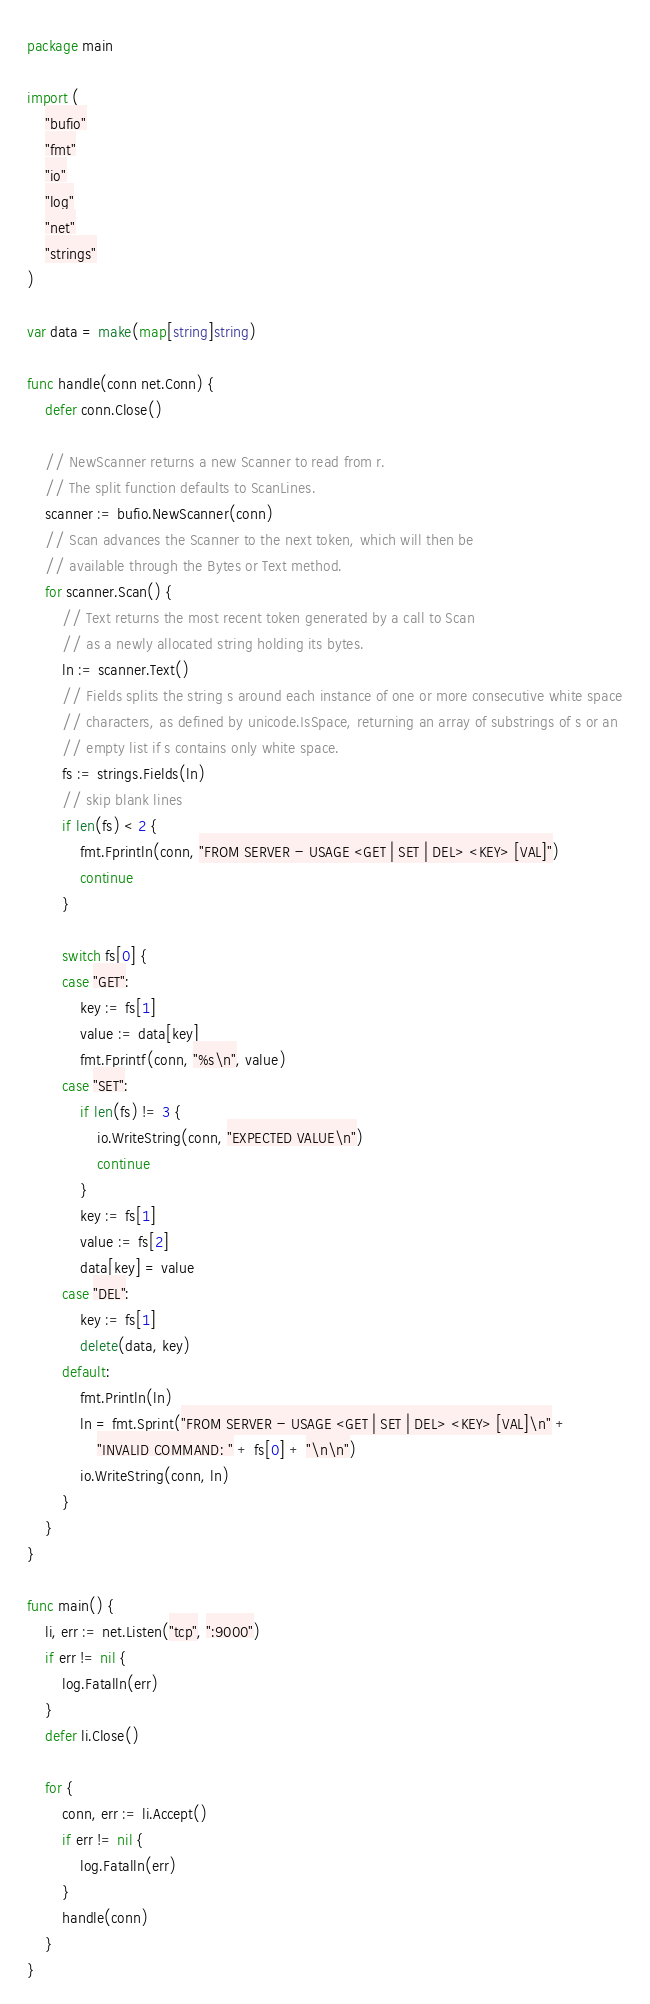Convert code to text. <code><loc_0><loc_0><loc_500><loc_500><_Go_>package main

import (
	"bufio"
	"fmt"
	"io"
	"log"
	"net"
	"strings"
)

var data = make(map[string]string)

func handle(conn net.Conn) {
	defer conn.Close()

	// NewScanner returns a new Scanner to read from r.
	// The split function defaults to ScanLines.
	scanner := bufio.NewScanner(conn)
	// Scan advances the Scanner to the next token, which will then be
	// available through the Bytes or Text method.
	for scanner.Scan() {
		// Text returns the most recent token generated by a call to Scan
		// as a newly allocated string holding its bytes.
		ln := scanner.Text()
		// Fields splits the string s around each instance of one or more consecutive white space
		// characters, as defined by unicode.IsSpace, returning an array of substrings of s or an
		// empty list if s contains only white space.
		fs := strings.Fields(ln)
		// skip blank lines
		if len(fs) < 2 {
			fmt.Fprintln(conn, "FROM SERVER - USAGE <GET | SET | DEL> <KEY> [VAL]")
			continue
		}

		switch fs[0] {
		case "GET":
			key := fs[1]
			value := data[key]
			fmt.Fprintf(conn, "%s\n", value)
		case "SET":
			if len(fs) != 3 {
				io.WriteString(conn, "EXPECTED VALUE\n")
				continue
			}
			key := fs[1]
			value := fs[2]
			data[key] = value
		case "DEL":
			key := fs[1]
			delete(data, key)
		default:
			fmt.Println(ln)
			ln = fmt.Sprint("FROM SERVER - USAGE <GET | SET | DEL> <KEY> [VAL]\n" +
				"INVALID COMMAND: " + fs[0] + "\n\n")
			io.WriteString(conn, ln)
		}
	}
}

func main() {
	li, err := net.Listen("tcp", ":9000")
	if err != nil {
		log.Fatalln(err)
	}
	defer li.Close()

	for {
		conn, err := li.Accept()
		if err != nil {
			log.Fatalln(err)
		}
		handle(conn)
	}
}
</code> 